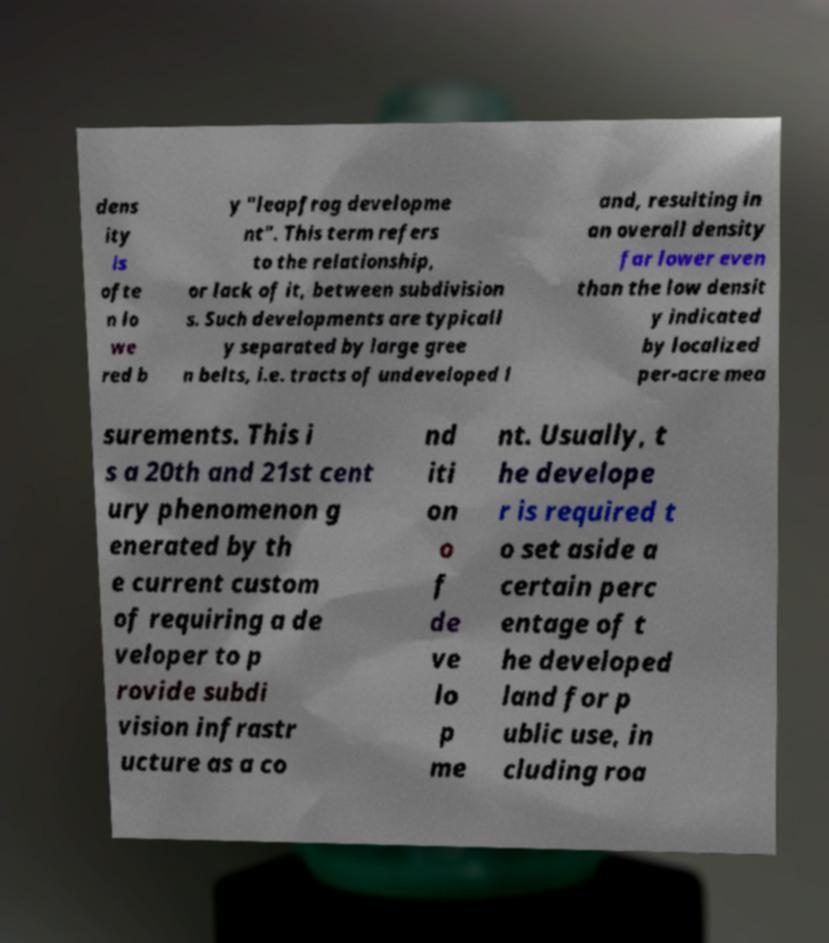Please read and relay the text visible in this image. What does it say? dens ity is ofte n lo we red b y "leapfrog developme nt". This term refers to the relationship, or lack of it, between subdivision s. Such developments are typicall y separated by large gree n belts, i.e. tracts of undeveloped l and, resulting in an overall density far lower even than the low densit y indicated by localized per-acre mea surements. This i s a 20th and 21st cent ury phenomenon g enerated by th e current custom of requiring a de veloper to p rovide subdi vision infrastr ucture as a co nd iti on o f de ve lo p me nt. Usually, t he develope r is required t o set aside a certain perc entage of t he developed land for p ublic use, in cluding roa 